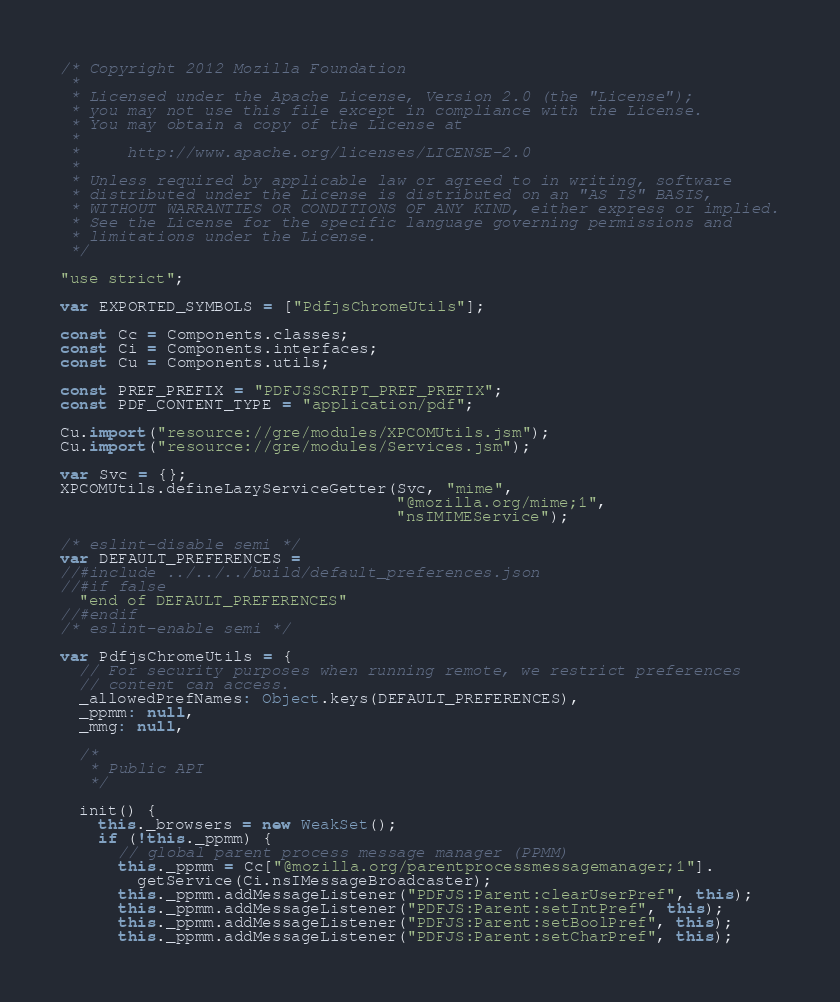Convert code to text. <code><loc_0><loc_0><loc_500><loc_500><_JavaScript_>/* Copyright 2012 Mozilla Foundation
 *
 * Licensed under the Apache License, Version 2.0 (the "License");
 * you may not use this file except in compliance with the License.
 * You may obtain a copy of the License at
 *
 *     http://www.apache.org/licenses/LICENSE-2.0
 *
 * Unless required by applicable law or agreed to in writing, software
 * distributed under the License is distributed on an "AS IS" BASIS,
 * WITHOUT WARRANTIES OR CONDITIONS OF ANY KIND, either express or implied.
 * See the License for the specific language governing permissions and
 * limitations under the License.
 */

"use strict";

var EXPORTED_SYMBOLS = ["PdfjsChromeUtils"];

const Cc = Components.classes;
const Ci = Components.interfaces;
const Cu = Components.utils;

const PREF_PREFIX = "PDFJSSCRIPT_PREF_PREFIX";
const PDF_CONTENT_TYPE = "application/pdf";

Cu.import("resource://gre/modules/XPCOMUtils.jsm");
Cu.import("resource://gre/modules/Services.jsm");

var Svc = {};
XPCOMUtils.defineLazyServiceGetter(Svc, "mime",
                                   "@mozilla.org/mime;1",
                                   "nsIMIMEService");

/* eslint-disable semi */
var DEFAULT_PREFERENCES =
//#include ../../../build/default_preferences.json
//#if false
  "end of DEFAULT_PREFERENCES"
//#endif
/* eslint-enable semi */

var PdfjsChromeUtils = {
  // For security purposes when running remote, we restrict preferences
  // content can access.
  _allowedPrefNames: Object.keys(DEFAULT_PREFERENCES),
  _ppmm: null,
  _mmg: null,

  /*
   * Public API
   */

  init() {
    this._browsers = new WeakSet();
    if (!this._ppmm) {
      // global parent process message manager (PPMM)
      this._ppmm = Cc["@mozilla.org/parentprocessmessagemanager;1"].
        getService(Ci.nsIMessageBroadcaster);
      this._ppmm.addMessageListener("PDFJS:Parent:clearUserPref", this);
      this._ppmm.addMessageListener("PDFJS:Parent:setIntPref", this);
      this._ppmm.addMessageListener("PDFJS:Parent:setBoolPref", this);
      this._ppmm.addMessageListener("PDFJS:Parent:setCharPref", this);</code> 